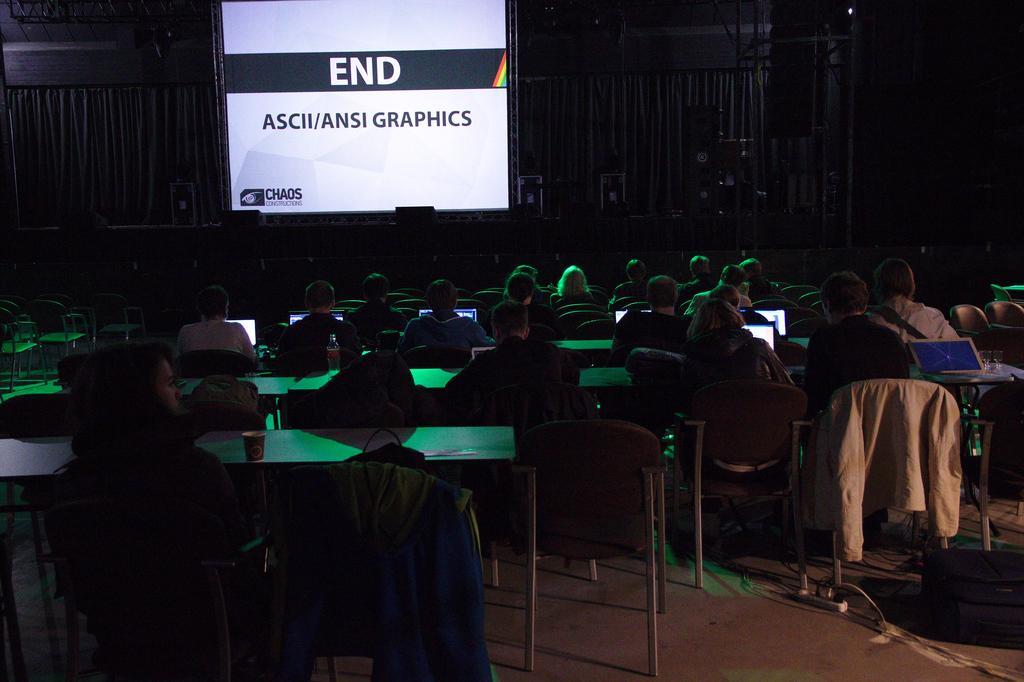Could you give a brief overview of what you see in this image? In this picture we can see there are groups of people sitting on chairs and in front of the people there are tables and on the tables there are laptops, cup, and a bottle. In front of the people there is a projector screen and other things. 